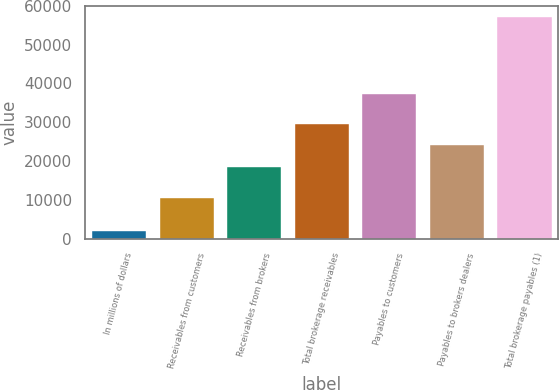Convert chart to OTSL. <chart><loc_0><loc_0><loc_500><loc_500><bar_chart><fcel>In millions of dollars<fcel>Receivables from customers<fcel>Receivables from brokers<fcel>Total brokerage receivables<fcel>Payables to customers<fcel>Payables to brokers dealers<fcel>Total brokerage payables (1)<nl><fcel>2016<fcel>10374<fcel>18513<fcel>29540.2<fcel>37237<fcel>24026.6<fcel>57152<nl></chart> 